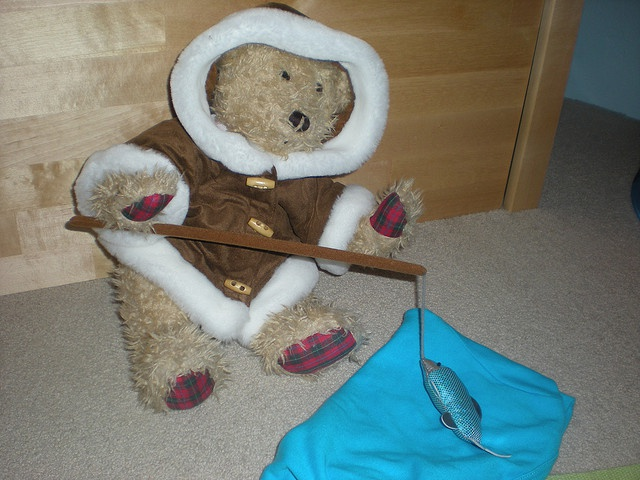Describe the objects in this image and their specific colors. I can see teddy bear in gray, darkgray, and lightgray tones and handbag in gray, lightblue, teal, and blue tones in this image. 